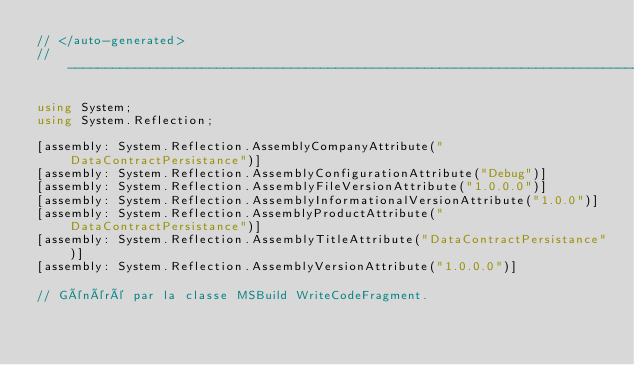<code> <loc_0><loc_0><loc_500><loc_500><_C#_>// </auto-generated>
//------------------------------------------------------------------------------

using System;
using System.Reflection;

[assembly: System.Reflection.AssemblyCompanyAttribute("DataContractPersistance")]
[assembly: System.Reflection.AssemblyConfigurationAttribute("Debug")]
[assembly: System.Reflection.AssemblyFileVersionAttribute("1.0.0.0")]
[assembly: System.Reflection.AssemblyInformationalVersionAttribute("1.0.0")]
[assembly: System.Reflection.AssemblyProductAttribute("DataContractPersistance")]
[assembly: System.Reflection.AssemblyTitleAttribute("DataContractPersistance")]
[assembly: System.Reflection.AssemblyVersionAttribute("1.0.0.0")]

// Généré par la classe MSBuild WriteCodeFragment.

</code> 